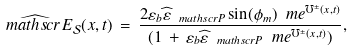Convert formula to latex. <formula><loc_0><loc_0><loc_500><loc_500>\widehat { \ m a t h s c r { E } } _ { \mathcal { S } } ( x , t ) \, = \, \frac { 2 \varepsilon _ { b } \widehat { \varepsilon } _ { \ m a t h s c r { P } } \sin ( \phi _ { m } ) \ m e ^ { \mho ^ { \pm } ( x , t ) } } { ( 1 \, + \, \varepsilon _ { b } \widehat { \varepsilon } _ { \ m a t h s c r { P } } \ m e ^ { \mho ^ { \pm } ( x , t ) } ) } ,</formula> 